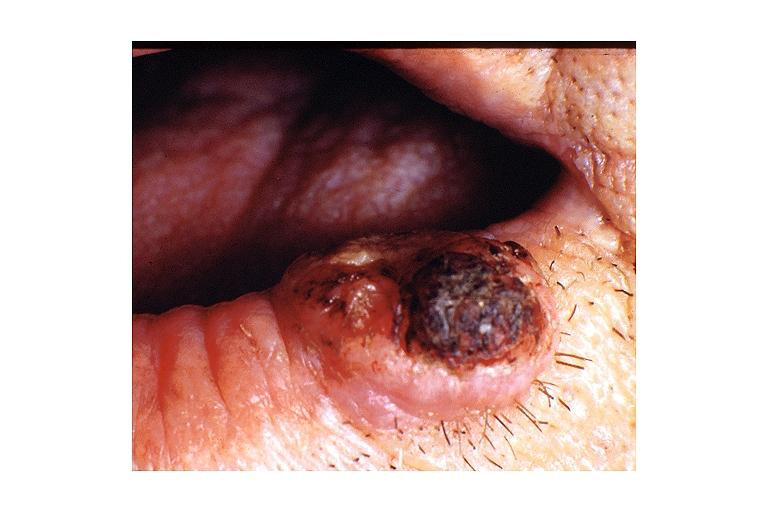what is present?
Answer the question using a single word or phrase. Oral 